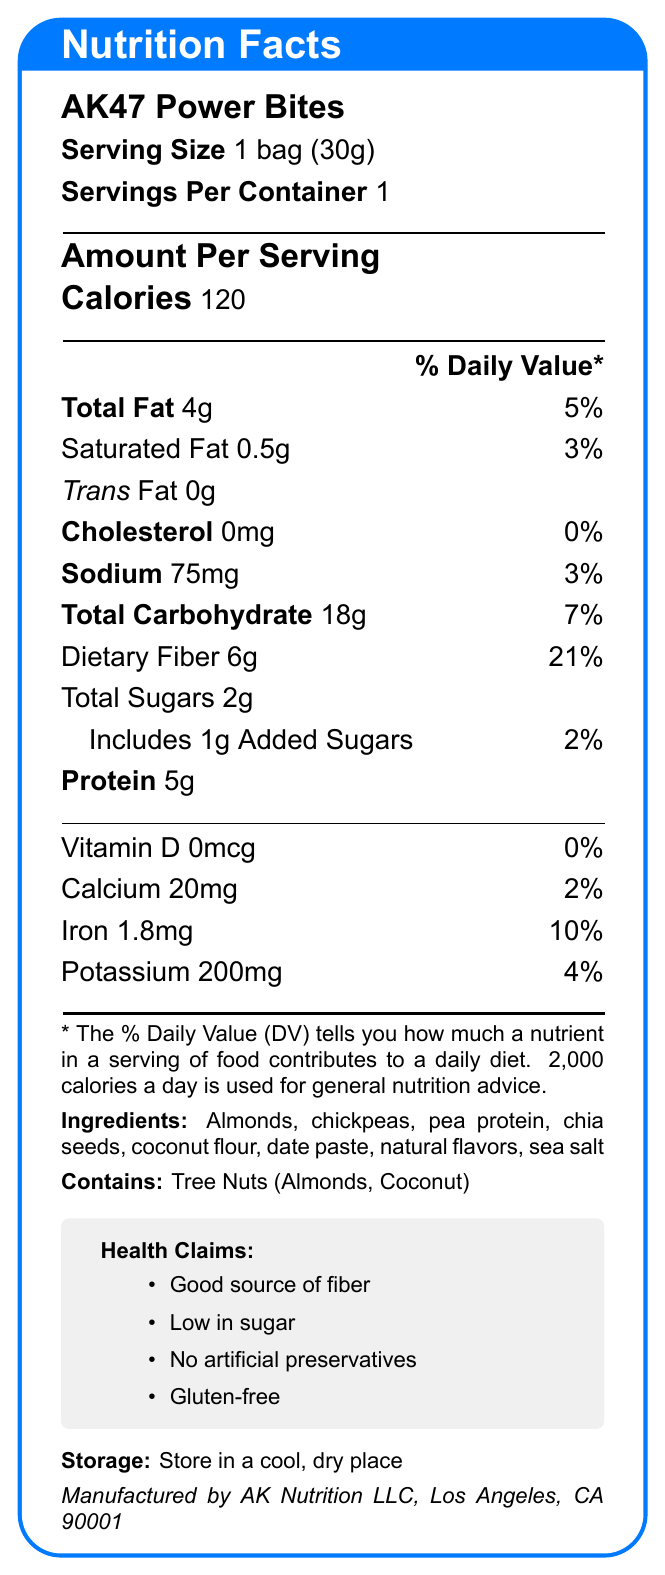what is the serving size of AK47 Power Bites? The serving size is clearly mentioned as "1 bag (30g)" in the document.
Answer: 1 bag (30g) how many calories are in one serving of AK47 Power Bites? The document states in the "Amount Per Serving" section that there are 120 calories.
Answer: 120 what percentage of the daily value for dietary fiber does one serving of AK47 Power Bites provide? The dietary fiber amount is listed as 6g and its daily value percentage as 21%.
Answer: 21% what is the total fat content in AK47 Power Bites? The total fat content is shown as 4g.
Answer: 4g which two ingredients in AK47 Power Bites are tree nuts? A. Almonds and Chia seeds B. Chia seeds and Coconut C. Almonds and Coconut The allergen information states that the product contains tree nuts: Almonds and Coconut.
Answer: C what is the main component providing protein in AK47 Power Bites? According to the ingredient list, pea protein is the main protein component.
Answer: Pea protein do AK47 Power Bites contain any cholesterol? The document clearly indicates 0mg of cholesterol.
Answer: No are there any artificial preservatives in AK47 Power Bites? One of the health claims states "No artificial preservatives."
Answer: No summarize the overall nutritional profile of AK47 Power Bites. The summary includes the main nutritional points and highlights some health claims.
Answer: AK47 Power Bites are a healthy snack with 120 calories per serving, low in sugar (2g total sugars) and a good source of dietary fiber (21% DV). They contain 5g of protein, 4g of total fat (with only 0.5g of saturated fat), and minimal sodium (3% DV). The snack is also free of cholesterol and artificial preservatives, and is gluten-free. do AK47 Power Bites contain gluten? The document mentions "Gluten-free" under health claims.
Answer: No how much potassium is present in one serving of AK47 Power Bites? The potassium content is listed as 200mg, contributing 4% of the daily value.
Answer: 200mg which company manufactures AK47 Power Bites? The manufacturer information is given at the end of the document.
Answer: AK Nutrition LLC, Los Angeles, CA 90001 what is the sodium content per serving in AK47 Power Bites? A. 20mg B. 75mg C. 150mg The sodium content per serving is listed as 75mg, which corresponds to option B.
Answer: B what other products does AK Nutrition LLC offer? The document does not provide any information about other products offered by AK Nutrition LLC.
Answer: Not enough information where should AK47 Power Bites be stored? The storage instructions specify storing the product in a cool, dry place.
Answer: In a cool, dry place 